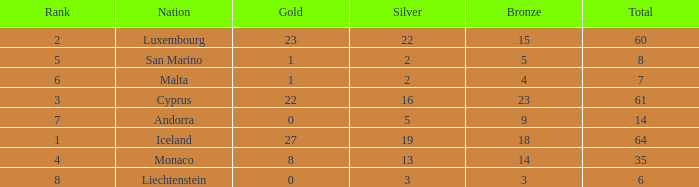How many bronzes for Iceland with over 2 silvers? 18.0. 